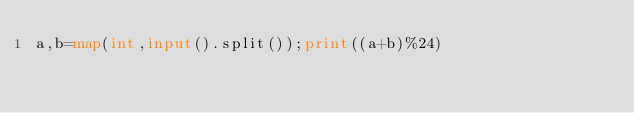Convert code to text. <code><loc_0><loc_0><loc_500><loc_500><_Python_>a,b=map(int,input().split());print((a+b)%24)</code> 